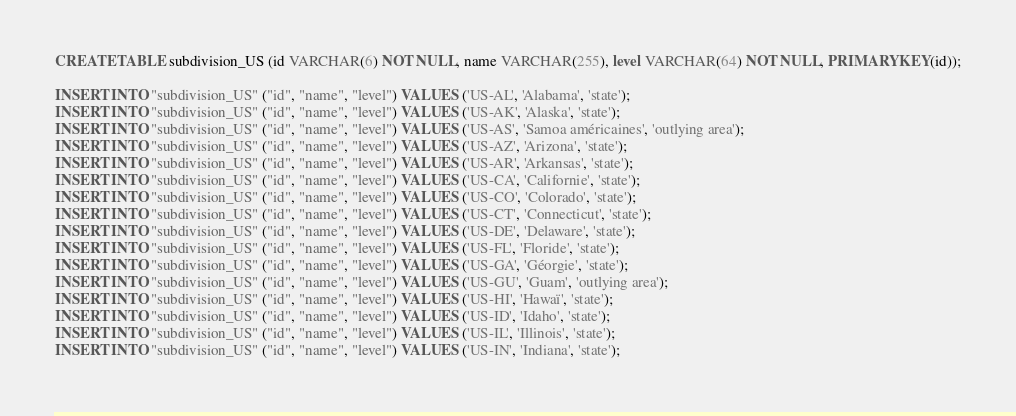Convert code to text. <code><loc_0><loc_0><loc_500><loc_500><_SQL_>CREATE TABLE subdivision_US (id VARCHAR(6) NOT NULL, name VARCHAR(255), level VARCHAR(64) NOT NULL, PRIMARY KEY(id));

INSERT INTO "subdivision_US" ("id", "name", "level") VALUES ('US-AL', 'Alabama', 'state');
INSERT INTO "subdivision_US" ("id", "name", "level") VALUES ('US-AK', 'Alaska', 'state');
INSERT INTO "subdivision_US" ("id", "name", "level") VALUES ('US-AS', 'Samoa américaines', 'outlying area');
INSERT INTO "subdivision_US" ("id", "name", "level") VALUES ('US-AZ', 'Arizona', 'state');
INSERT INTO "subdivision_US" ("id", "name", "level") VALUES ('US-AR', 'Arkansas', 'state');
INSERT INTO "subdivision_US" ("id", "name", "level") VALUES ('US-CA', 'Californie', 'state');
INSERT INTO "subdivision_US" ("id", "name", "level") VALUES ('US-CO', 'Colorado', 'state');
INSERT INTO "subdivision_US" ("id", "name", "level") VALUES ('US-CT', 'Connecticut', 'state');
INSERT INTO "subdivision_US" ("id", "name", "level") VALUES ('US-DE', 'Delaware', 'state');
INSERT INTO "subdivision_US" ("id", "name", "level") VALUES ('US-FL', 'Floride', 'state');
INSERT INTO "subdivision_US" ("id", "name", "level") VALUES ('US-GA', 'Géorgie', 'state');
INSERT INTO "subdivision_US" ("id", "name", "level") VALUES ('US-GU', 'Guam', 'outlying area');
INSERT INTO "subdivision_US" ("id", "name", "level") VALUES ('US-HI', 'Hawaï', 'state');
INSERT INTO "subdivision_US" ("id", "name", "level") VALUES ('US-ID', 'Idaho', 'state');
INSERT INTO "subdivision_US" ("id", "name", "level") VALUES ('US-IL', 'Illinois', 'state');
INSERT INTO "subdivision_US" ("id", "name", "level") VALUES ('US-IN', 'Indiana', 'state');</code> 